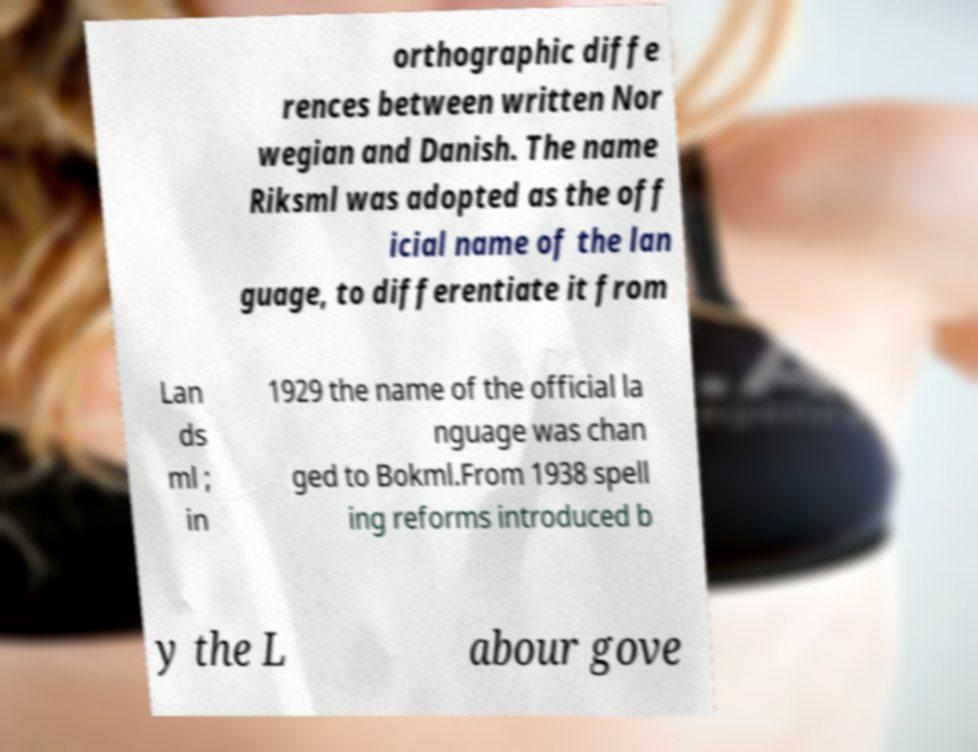For documentation purposes, I need the text within this image transcribed. Could you provide that? orthographic diffe rences between written Nor wegian and Danish. The name Riksml was adopted as the off icial name of the lan guage, to differentiate it from Lan ds ml ; in 1929 the name of the official la nguage was chan ged to Bokml.From 1938 spell ing reforms introduced b y the L abour gove 